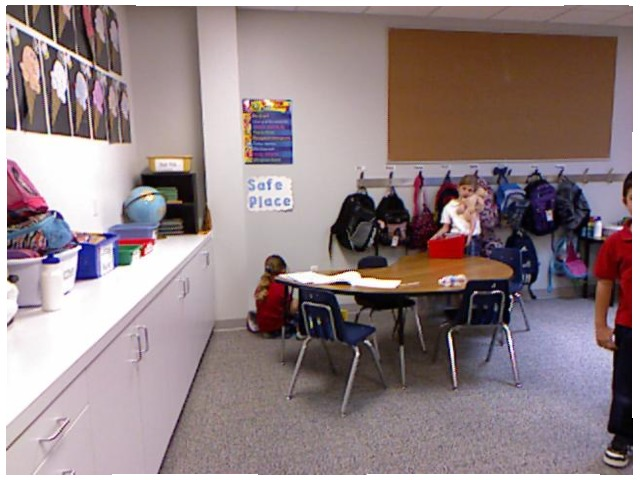<image>
Can you confirm if the stuffed animal is to the right of the girl? Yes. From this viewpoint, the stuffed animal is positioned to the right side relative to the girl. Is there a chair under the table? Yes. The chair is positioned underneath the table, with the table above it in the vertical space. Is there a globe behind the shelf? No. The globe is not behind the shelf. From this viewpoint, the globe appears to be positioned elsewhere in the scene. 